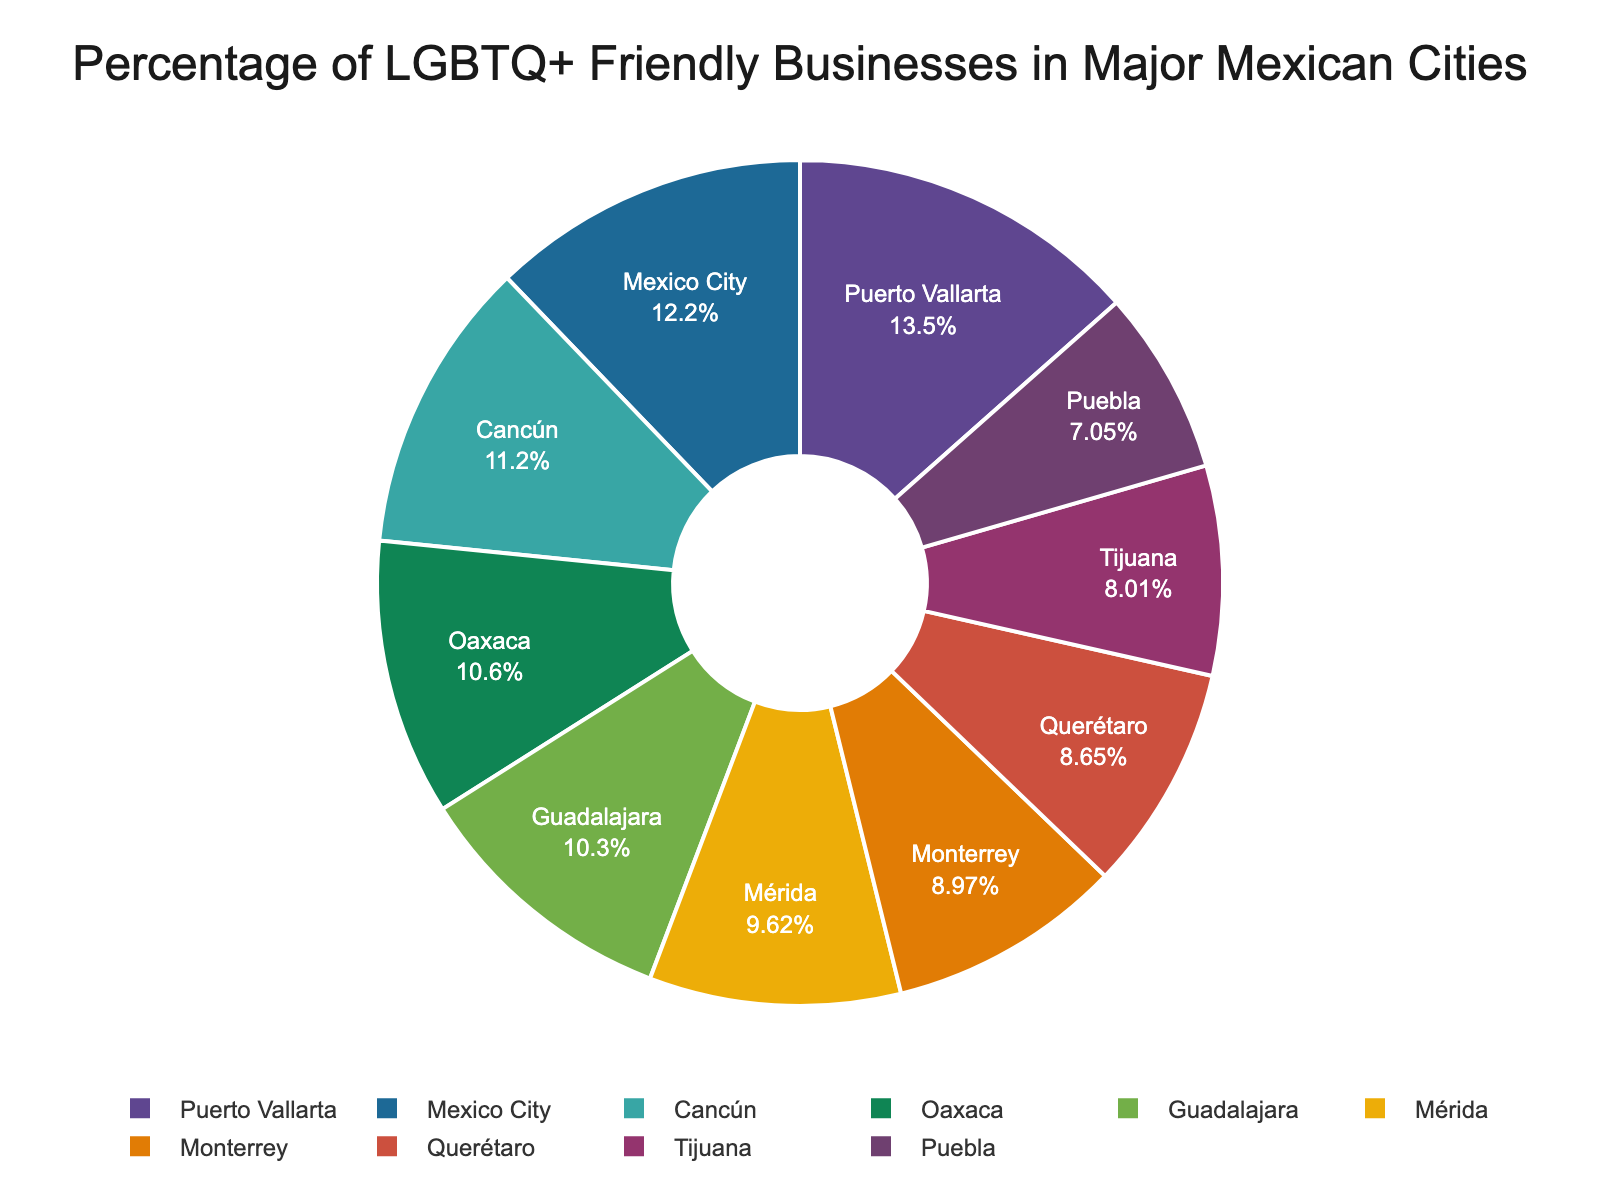Which city has the highest percentage of LGBTQ+ friendly businesses? Look at the pie chart and identify the segment with the largest percentage.
Answer: Puerto Vallarta Compare the percentage of LGBTQ+ friendly businesses in Mexico City and Guadalajara. Which city has a higher percentage? Compare the respective segments for Mexico City and Guadalajara by looking at their percentages. Mexico City has 38%, while Guadalajara has 32%.
Answer: Mexico City What is the difference in the percentage of LGBTQ+ friendly businesses between Tijuana and Puebla? Subtract the percentage of Puebla from the percentage of Tijuana: 25% - 22% = 3%.
Answer: 3% What is the sum of the percentages of LGBTQ+ friendly businesses in Mérida, Oaxaca, and Querétaro? Add the percentages for Mérida, Oaxaca, and Querétaro: 30% + 33% + 27% = 90%.
Answer: 90% Which city has the smallest percentage of LGBTQ+ friendly businesses, and what is that percentage? Identify the segment in the pie chart with the smallest percentage. Puebla has the smallest, at 22%.
Answer: Puebla, 22% Compare the percentage of LGBTQ+ friendly businesses in Monterrey and Cancún. Which city has a lower percentage? Compare the respective segments for Monterrey and Cancún by looking at their percentages. Monterrey has 28%, while Cancún has 35%.
Answer: Monterrey How many more percentage points does Puerto Vallarta have compared to Querétaro? Subtract the percentage of Querétaro from that of Puerto Vallarta: 42% - 27% = 15%.
Answer: 15% Which two cities have a combined percentage that is closest to 60%? Look for two cities whose sum of percentages is closest to 60%. Mérida (30%) and Querétaro (27%) sum to 57%, closest to 60%.
Answer: Mérida and Querétaro What is the median percentage of LGBTQ+ friendly businesses across all the cities? Order the percentages: 22, 25, 27, 28, 30, 32, 33, 35, 38, 42. The median is the average of the 5th and 6th values: (30 + 32) / 2 = 31%.
Answer: 31% Which city has a higher percentage of LGBTQ+ friendly businesses, Tijuana or Mérida? Compare the respective segments for Tijuana and Mérida by looking at their percentages. Mérida has 30%, Tijuana has 25%.
Answer: Mérida 